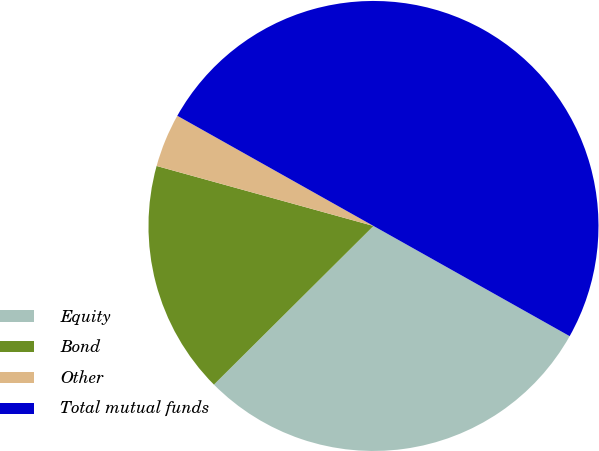Convert chart to OTSL. <chart><loc_0><loc_0><loc_500><loc_500><pie_chart><fcel>Equity<fcel>Bond<fcel>Other<fcel>Total mutual funds<nl><fcel>29.4%<fcel>16.75%<fcel>3.85%<fcel>50.0%<nl></chart> 